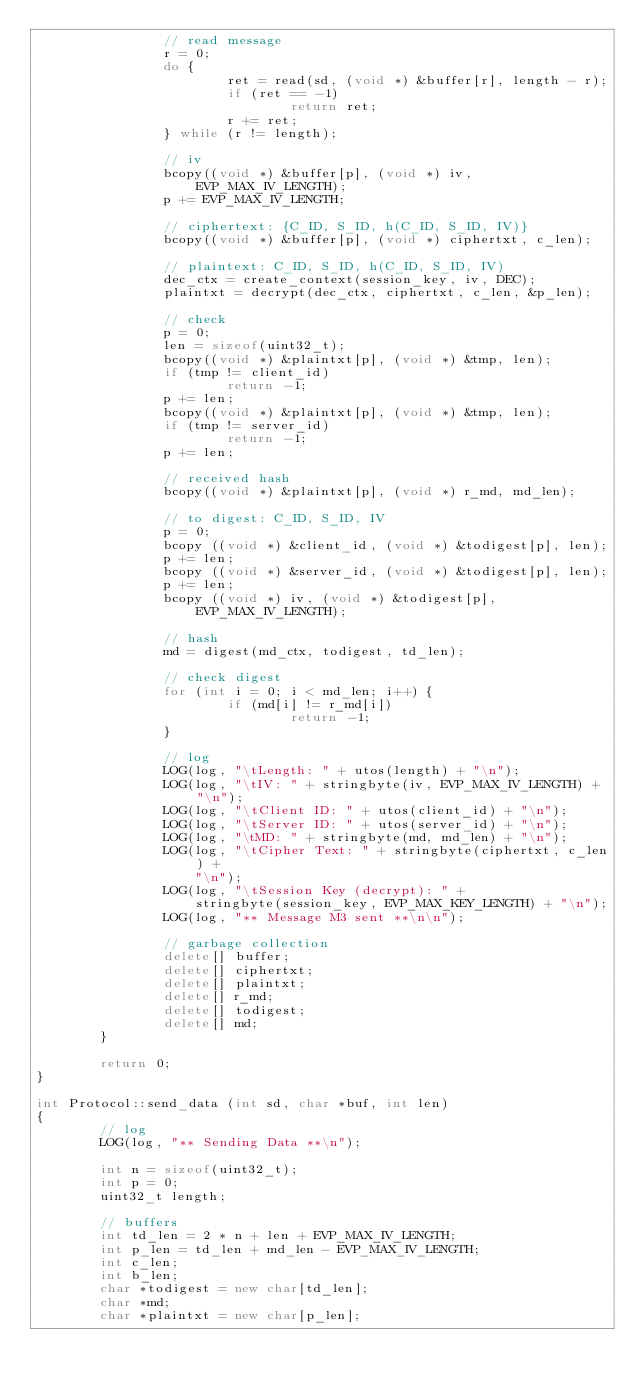<code> <loc_0><loc_0><loc_500><loc_500><_C++_>                // read message
                r = 0;
                do {
                        ret = read(sd, (void *) &buffer[r], length - r);
                        if (ret == -1)
                                return ret;
                        r += ret;
                } while (r != length);

                // iv
                bcopy((void *) &buffer[p], (void *) iv, EVP_MAX_IV_LENGTH);
                p += EVP_MAX_IV_LENGTH;

                // ciphertext: {C_ID, S_ID, h(C_ID, S_ID, IV)}
                bcopy((void *) &buffer[p], (void *) ciphertxt, c_len);

                // plaintext: C_ID, S_ID, h(C_ID, S_ID, IV)
                dec_ctx = create_context(session_key, iv, DEC);
                plaintxt = decrypt(dec_ctx, ciphertxt, c_len, &p_len);

                // check
                p = 0;
                len = sizeof(uint32_t);
                bcopy((void *) &plaintxt[p], (void *) &tmp, len);
                if (tmp != client_id)
                        return -1;
                p += len;
                bcopy((void *) &plaintxt[p], (void *) &tmp, len);
                if (tmp != server_id)
                        return -1;
                p += len;

                // received hash
                bcopy((void *) &plaintxt[p], (void *) r_md, md_len);

                // to digest: C_ID, S_ID, IV
                p = 0;
                bcopy ((void *) &client_id, (void *) &todigest[p], len);
                p += len;
                bcopy ((void *) &server_id, (void *) &todigest[p], len);
                p += len;
                bcopy ((void *) iv, (void *) &todigest[p], EVP_MAX_IV_LENGTH);

                // hash
                md = digest(md_ctx, todigest, td_len);

                // check digest
                for (int i = 0; i < md_len; i++) {
                        if (md[i] != r_md[i])
                                return -1;
                }

                // log
                LOG(log, "\tLength: " + utos(length) + "\n");
                LOG(log, "\tIV: " + stringbyte(iv, EVP_MAX_IV_LENGTH) + "\n");
                LOG(log, "\tClient ID: " + utos(client_id) + "\n");
                LOG(log, "\tServer ID: " + utos(server_id) + "\n");
                LOG(log, "\tMD: " + stringbyte(md, md_len) + "\n");
                LOG(log, "\tCipher Text: " + stringbyte(ciphertxt, c_len) +
                    "\n");
                LOG(log, "\tSession Key (decrypt): " + 
                    stringbyte(session_key, EVP_MAX_KEY_LENGTH) + "\n");
                LOG(log, "** Message M3 sent **\n\n");

                // garbage collection
                delete[] buffer;
                delete[] ciphertxt;
                delete[] plaintxt;
                delete[] r_md;
                delete[] todigest;
                delete[] md;
        }

        return 0;
}

int Protocol::send_data (int sd, char *buf, int len)
{
        // log
        LOG(log, "** Sending Data **\n");

        int n = sizeof(uint32_t);
        int p = 0;
        uint32_t length;

        // buffers
        int td_len = 2 * n + len + EVP_MAX_IV_LENGTH;
        int p_len = td_len + md_len - EVP_MAX_IV_LENGTH;
        int c_len;
        int b_len;
        char *todigest = new char[td_len];
        char *md;
        char *plaintxt = new char[p_len];</code> 